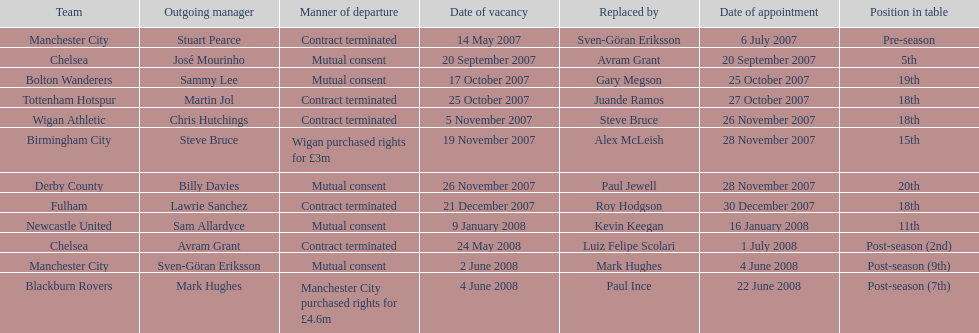Could you help me parse every detail presented in this table? {'header': ['Team', 'Outgoing manager', 'Manner of departure', 'Date of vacancy', 'Replaced by', 'Date of appointment', 'Position in table'], 'rows': [['Manchester City', 'Stuart Pearce', 'Contract terminated', '14 May 2007', 'Sven-Göran Eriksson', '6 July 2007', 'Pre-season'], ['Chelsea', 'José Mourinho', 'Mutual consent', '20 September 2007', 'Avram Grant', '20 September 2007', '5th'], ['Bolton Wanderers', 'Sammy Lee', 'Mutual consent', '17 October 2007', 'Gary Megson', '25 October 2007', '19th'], ['Tottenham Hotspur', 'Martin Jol', 'Contract terminated', '25 October 2007', 'Juande Ramos', '27 October 2007', '18th'], ['Wigan Athletic', 'Chris Hutchings', 'Contract terminated', '5 November 2007', 'Steve Bruce', '26 November 2007', '18th'], ['Birmingham City', 'Steve Bruce', 'Wigan purchased rights for £3m', '19 November 2007', 'Alex McLeish', '28 November 2007', '15th'], ['Derby County', 'Billy Davies', 'Mutual consent', '26 November 2007', 'Paul Jewell', '28 November 2007', '20th'], ['Fulham', 'Lawrie Sanchez', 'Contract terminated', '21 December 2007', 'Roy Hodgson', '30 December 2007', '18th'], ['Newcastle United', 'Sam Allardyce', 'Mutual consent', '9 January 2008', 'Kevin Keegan', '16 January 2008', '11th'], ['Chelsea', 'Avram Grant', 'Contract terminated', '24 May 2008', 'Luiz Felipe Scolari', '1 July 2008', 'Post-season (2nd)'], ['Manchester City', 'Sven-Göran Eriksson', 'Mutual consent', '2 June 2008', 'Mark Hughes', '4 June 2008', 'Post-season (9th)'], ['Blackburn Rovers', 'Mark Hughes', 'Manchester City purchased rights for £4.6m', '4 June 2008', 'Paul Ince', '22 June 2008', 'Post-season (7th)']]} After manchester city, which team is mentioned next? Chelsea. 